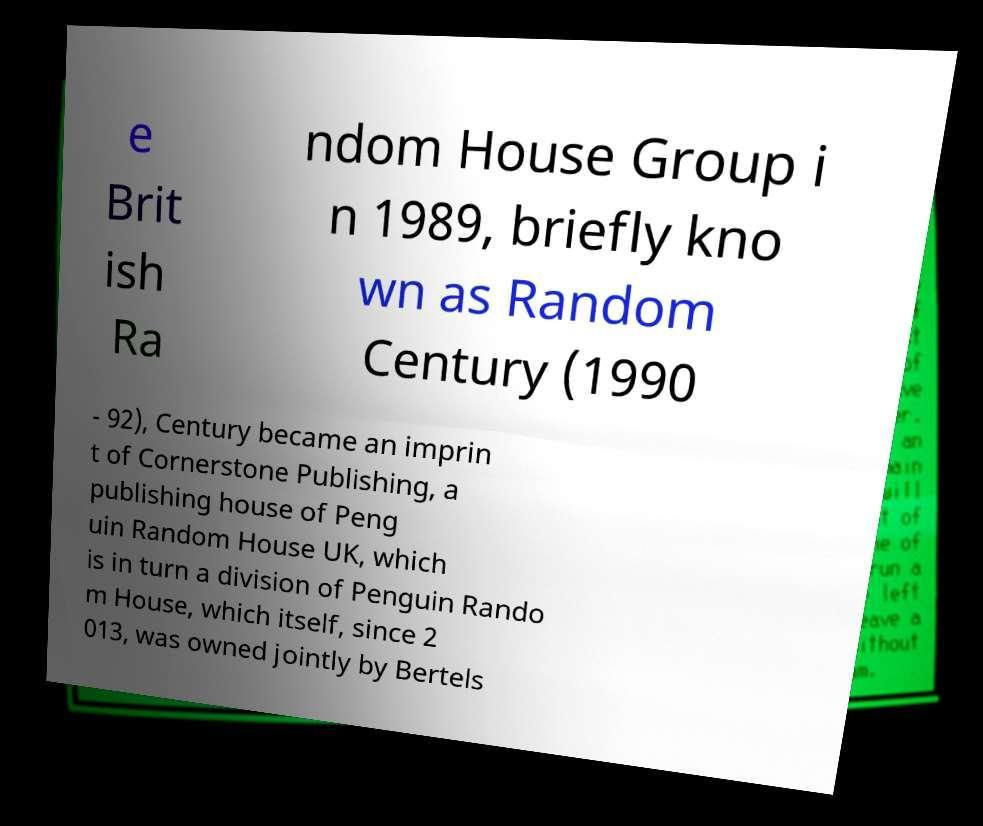Can you read and provide the text displayed in the image?This photo seems to have some interesting text. Can you extract and type it out for me? e Brit ish Ra ndom House Group i n 1989, briefly kno wn as Random Century (1990 - 92), Century became an imprin t of Cornerstone Publishing, a publishing house of Peng uin Random House UK, which is in turn a division of Penguin Rando m House, which itself, since 2 013, was owned jointly by Bertels 